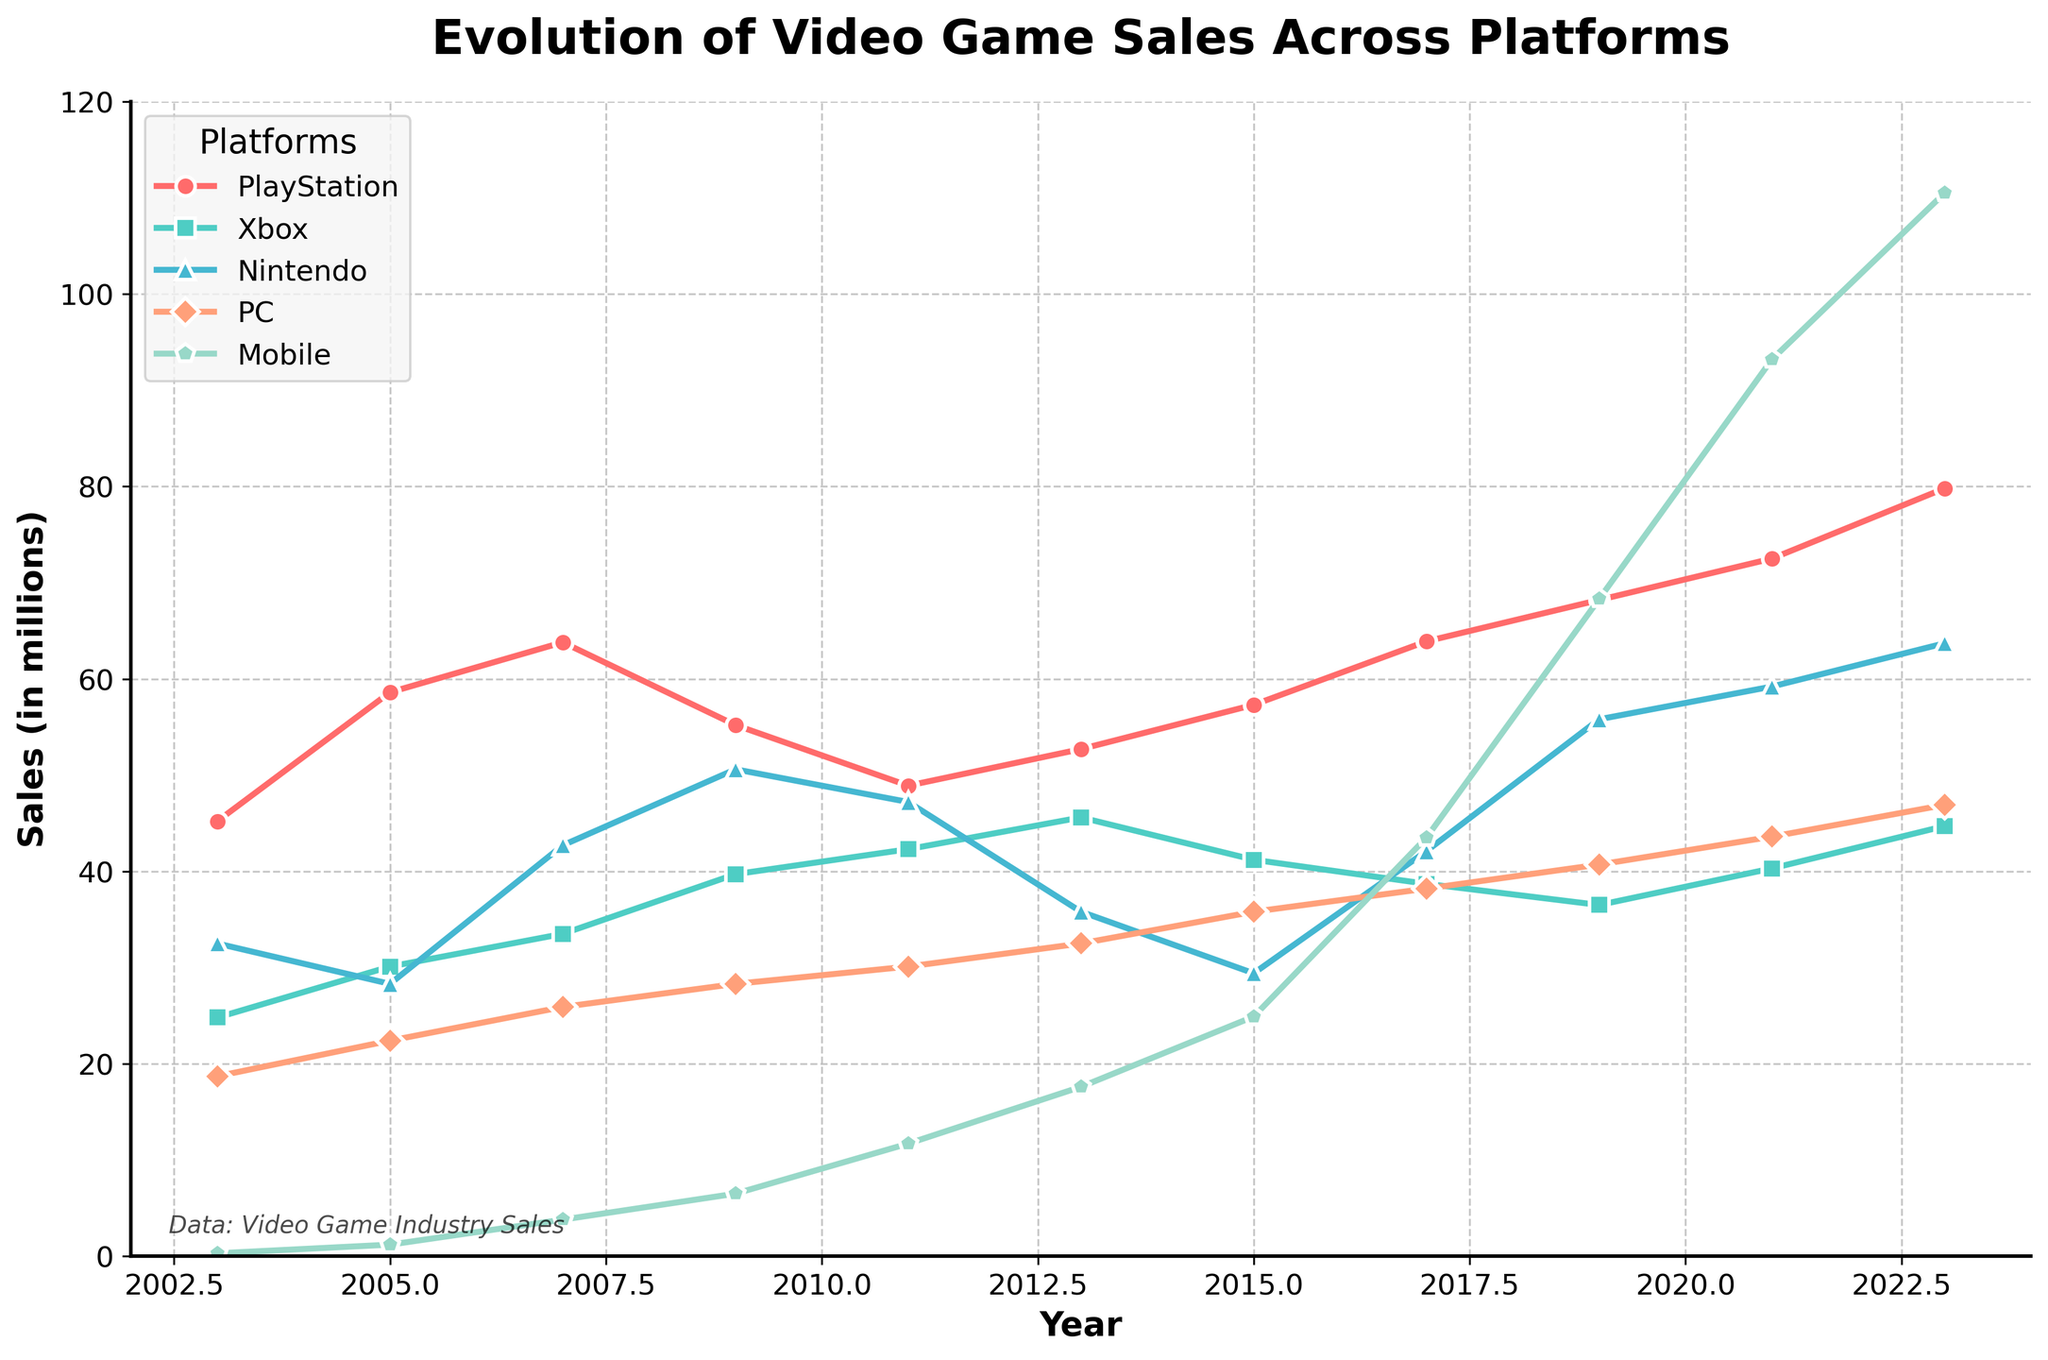What's the trend in PlayStation sales from 2003 to 2023? From 2003 to 2023, PlayStation sales show a general upward trend. Initially at 45.2 million in 2003, they rise continuously with minor fluctuations, reaching 79.8 million by 2023.
Answer: Upward trend Which platform had the highest sales in 2023? In 2023, Mobile had the highest sales at 110.5 million. By visually inspecting the lines representing different platforms, the Mobile line is the highest at the far right of the chart.
Answer: Mobile How did Nintendo sales compare to Xbox sales in 2017? In 2017, Nintendo sales (42.1 million) were higher than Xbox sales (38.7 million). Visually, the Nintendo line is positioned above the Xbox line for this year.
Answer: Nintendo What can be observed about PC sales from 2003 to 2023? PC sales show a gradual, consistent increase from 2003 (18.7 million) to 2023 (46.9 million). By observing the slope of the PC line on the graph, you can see it increases steadily without major dips.
Answer: Gradual increase By how much did Mobile sales increase between 2003 and 2023? To find the increase, subtract the sales figures: 110.5 million (2023) - 0.3 million (2003) = 110.2 million.
Answer: 110.2 million In which year did Nintendo reach its peak sales, and what was the value? Nintendo reached its peak sales in 2023 with 63.7 million. By tracing the highest point of the Nintendo line, it's observed at the far right of the chart.
Answer: 2023, 63.7 million Which platform experienced the most consistent growth over the 20 years? Mobile sales show the most consistent growth, steadily increasing from 0.3 million in 2003 to 110.5 million in 2023 without any dips.
Answer: Mobile How do the sales of PlayStation and Xbox compare in the year 2011? In 2011, PlayStation sales were 48.9 million, and Xbox sales were 42.3 million. The PlayStation line is positioned slightly higher than the Xbox line for this year.
Answer: PlayStation What is the average sales of PC from 2003 to 2023? To find the average, add the sales figures from 2003 to 2023, then divide by the number of years: (18.7 + 22.4 + 25.9 + 28.3 + 30.1 + 32.5 + 35.8 + 38.2 + 40.7 + 43.6 + 46.9) / 11 = 33.6 million.
Answer: 33.6 million 